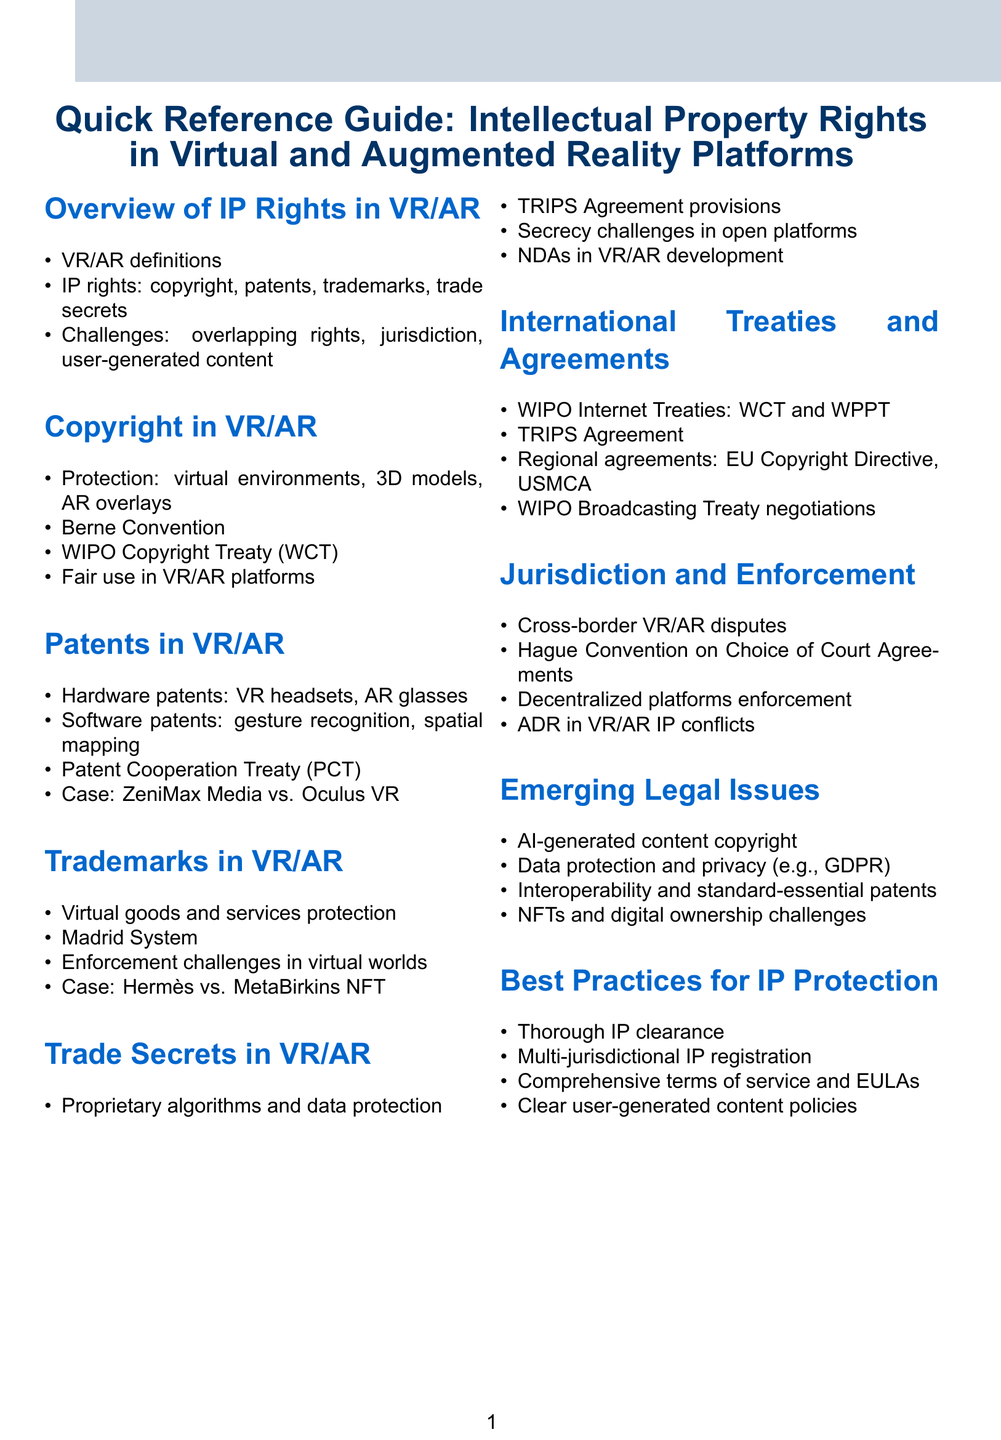What are the types of IP rights applicable in VR/AR? The document lists copyright, patents, trademarks, and trade secrets as the types of IP rights applicable in VR/AR.
Answer: copyright, patents, trademarks, trade secrets What international treaty addresses copyright protection in digital content? The WIPO Copyright Treaty (WCT) is mentioned as relevant to digital content.
Answer: WIPO Copyright Treaty (WCT) What notable patent dispute is mentioned in relation to VR? ZeniMax Media vs. Oculus VR is identified as a notable patent dispute in the document.
Answer: ZeniMax Media vs. Oculus VR Which agreement provides provisions on trade secrets? The TRIPS Agreement includes specific provisions on trade secrets.
Answer: TRIPS Agreement What legal issue arises with AI-generated content in VR/AR? Copyright implications are raised as a legal issue concerning AI-generated content in VR/AR.
Answer: copyright implications What system is used for international trademark registration? The Madrid System is used for international trademark registration, according to the document.
Answer: Madrid System What is a challenge in enforcing trademarks in virtual worlds? The document highlights enforcement challenges as a significant issue.
Answer: enforcement challenges What is a best practice for IP protection before launching VR/AR products? Conducting thorough IP clearance is suggested as a best practice before launching VR/AR products.
Answer: IP clearance What are the ongoing negotiations mentioned related to broadcasting? The WIPO Broadcasting Treaty negotiations are noted as ongoing negotiations in the content.
Answer: WIPO Broadcasting Treaty negotiations 